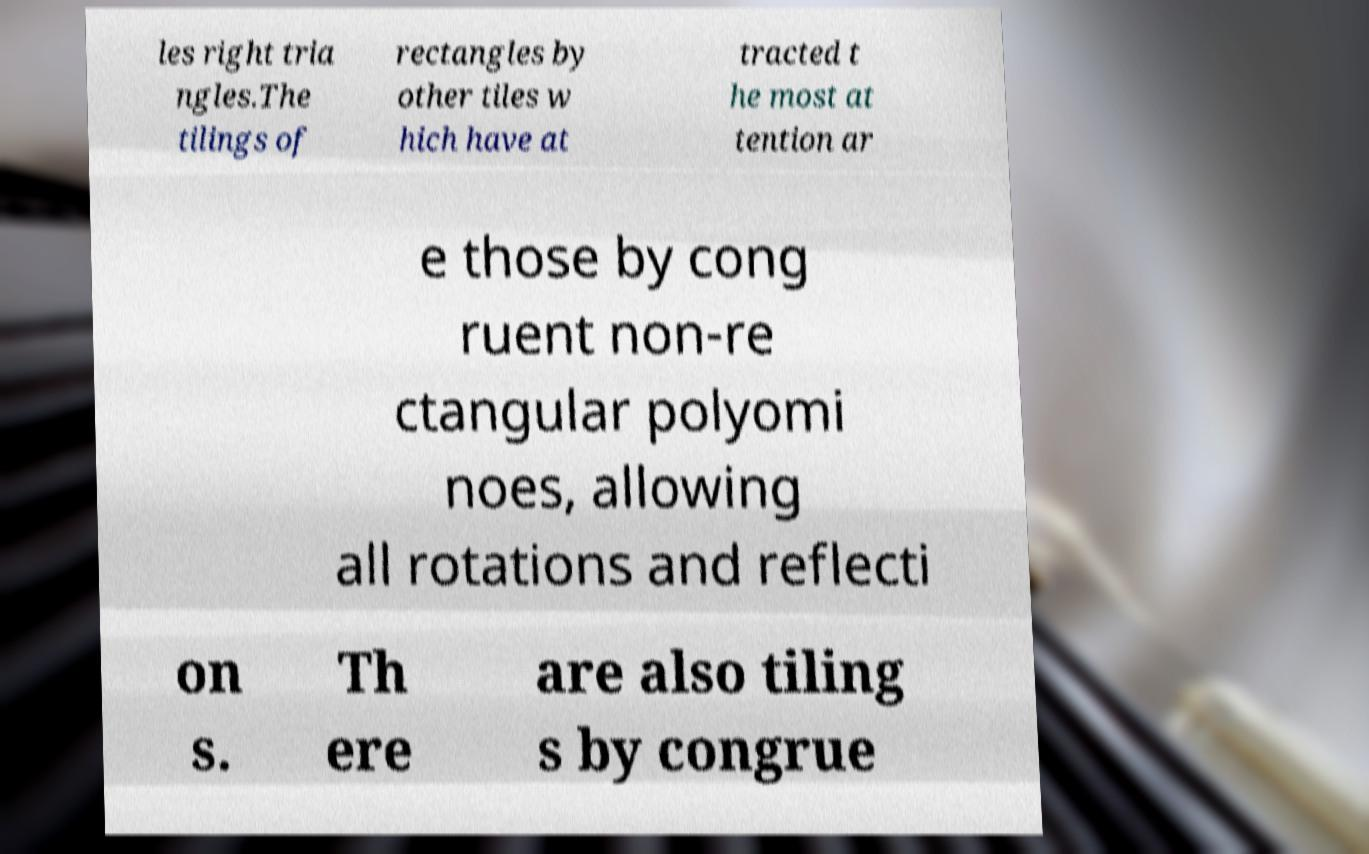Please identify and transcribe the text found in this image. les right tria ngles.The tilings of rectangles by other tiles w hich have at tracted t he most at tention ar e those by cong ruent non-re ctangular polyomi noes, allowing all rotations and reflecti on s. Th ere are also tiling s by congrue 